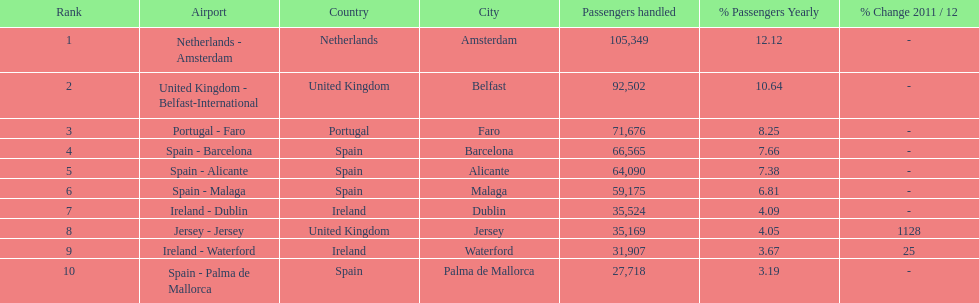Where is the most popular destination for passengers leaving london southend airport? Netherlands - Amsterdam. Could you parse the entire table as a dict? {'header': ['Rank', 'Airport', 'Country', 'City', 'Passengers handled', '% Passengers Yearly', '% Change 2011 / 12'], 'rows': [['1', 'Netherlands - Amsterdam', 'Netherlands', 'Amsterdam', '105,349', '12.12', '-'], ['2', 'United Kingdom - Belfast-International', 'United Kingdom', 'Belfast', '92,502', '10.64', '-'], ['3', 'Portugal - Faro', 'Portugal', 'Faro', '71,676', '8.25', '-'], ['4', 'Spain - Barcelona', 'Spain', 'Barcelona', '66,565', '7.66', '-'], ['5', 'Spain - Alicante', 'Spain', 'Alicante', '64,090', '7.38', '-'], ['6', 'Spain - Malaga', 'Spain', 'Malaga', '59,175', '6.81', '-'], ['7', 'Ireland - Dublin', 'Ireland', 'Dublin', '35,524', '4.09', '-'], ['8', 'Jersey - Jersey', 'United Kingdom', 'Jersey', '35,169', '4.05', '1128'], ['9', 'Ireland - Waterford', 'Ireland', 'Waterford', '31,907', '3.67', '25'], ['10', 'Spain - Palma de Mallorca', 'Spain', 'Palma de Mallorca', '27,718', '3.19', '-']]} 